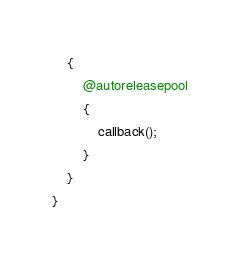<code> <loc_0><loc_0><loc_500><loc_500><_ObjectiveC_>    {
        @autoreleasepool
        {
            callback();
        }
    }
}
</code> 